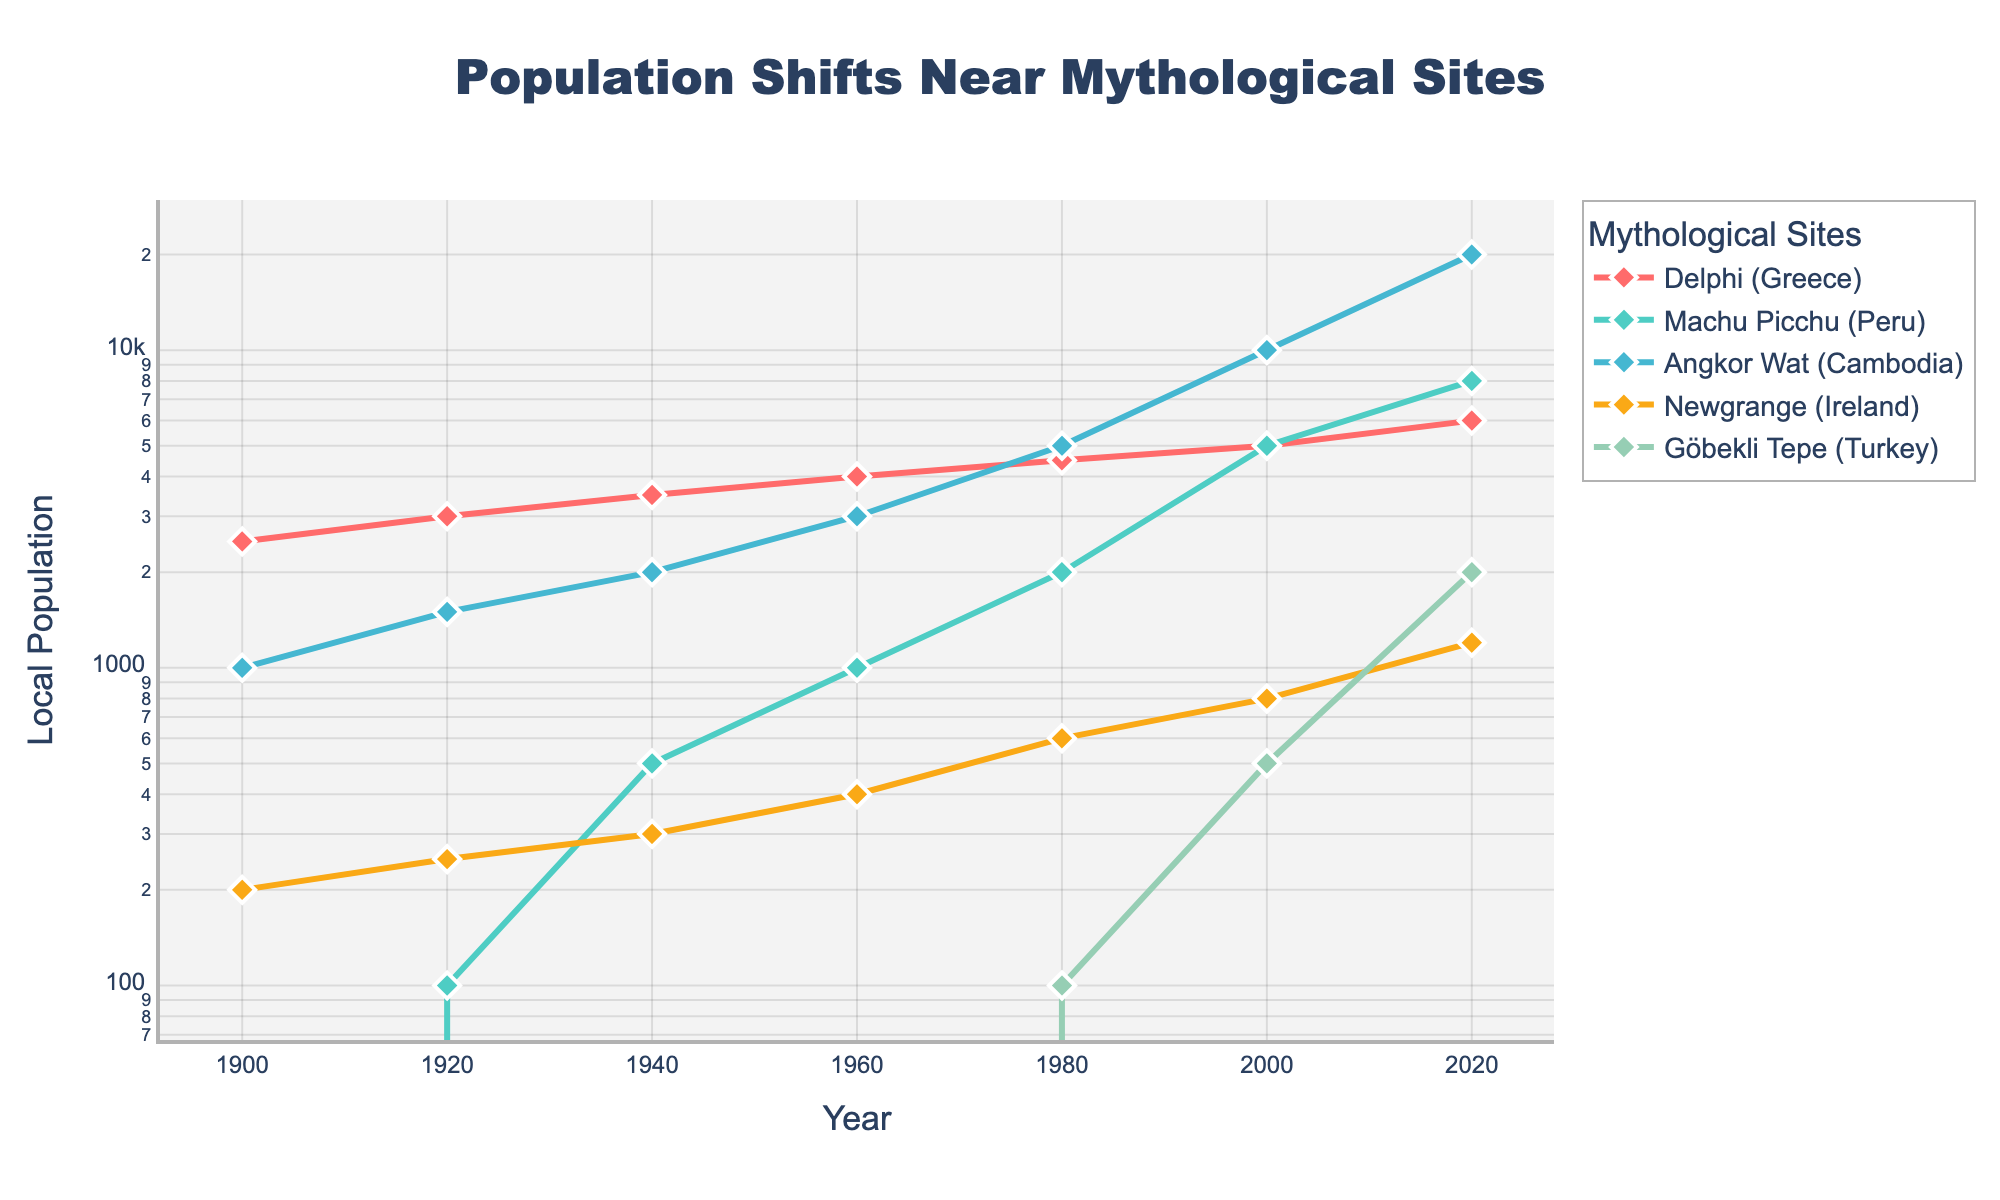Which site had the highest local population in 2020? Look for the peak value in the 2020 column in the chart. Angkor Wat (Cambodia) stands out with a population of 20,000.
Answer: Angkor Wat (Cambodia) What is the difference in population between Delphi and Machu Picchu in 1960? Locate the values for Delphi and Machu Picchu in 1960 from the chart. The values are 4000 and 1000 respectively. The difference is 4000 - 1000.
Answer: 3000 Which mythological site saw the most significant increase in local population between 1980 and 2000? Examine the figures for each site between 1980 and 2000. Göbekli Tepe (Turkey) increases from 100 to 500, Delphi (Greece) from 4500 to 5000, Machu Picchu (Peru) from 2000 to 5000, Newgrange (Ireland) from 600 to 800, and Angkor Wat (Cambodia) from 5000 to 10000. Angkor Wat saw the largest absolute increase of 5000.
Answer: Angkor Wat (Cambodia) What is the average local population near Göbekli Tepe from 1900 to 2020? Sum the values for Göbekli Tepe across the years (0 + 0 + 0 + 0 + 100 + 500 + 2000) which is 2600. Divide this sum by the number of data points, which is 7. 2600/7 ≈ 371.43.
Answer: 371.43 Which site had the slowest growth in local population from 1900 to 2020? Determine the overall change for each site from 1900 to 2020: Delphi (4500), Machu Picchu (8000), Angkor Wat (19000), Newgrange (1000), Göbekli Tepe (2000). The smallest growth is at Newgrange, which grew by 1000.
Answer: Newgrange (Ireland) Compare the populations of Angkor Wat and Delphi in the year 2000. Which one is larger and by how much? In 2000, Angkor Wat has a population of 10,000 while Delphi has 5,000. Subtract to find the difference: 10,000 - 5,000.
Answer: Angkor Wat is larger by 5,000 What year did Machu Picchu reach a local population of 5000? Look for the point on the Machu Picchu line that hits the 5000 mark. This happens in the year 2000.
Answer: 2000 What is the first year where Göbekli Tepe’s population is no longer zero? Track the values for Göbekli Tepe until it changes from zero to a positive number. This happens in 1980.
Answer: 1980 How does the population trend of Newgrange compare to that of Göbekli Tepe from 1900 to 1980? Observe the growth trends of both sites from the chart between 1900 and 1980. Newgrange shows a gradual increase, while Göbekli Tepe stays at zero.
Answer: Newgrange increased gradually, Göbekli Tepe remained zero 